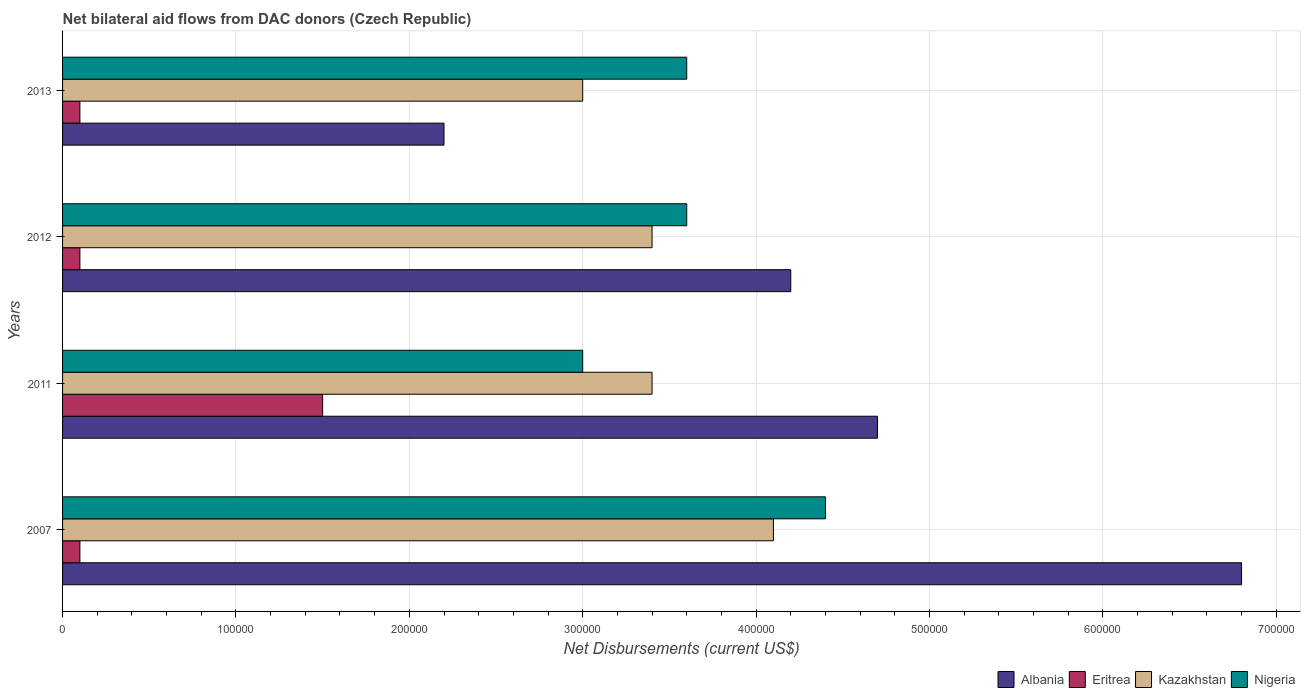How many different coloured bars are there?
Keep it short and to the point. 4. Are the number of bars per tick equal to the number of legend labels?
Offer a very short reply. Yes. What is the label of the 1st group of bars from the top?
Ensure brevity in your answer.  2013. What is the net bilateral aid flows in Nigeria in 2013?
Provide a succinct answer. 3.60e+05. Across all years, what is the maximum net bilateral aid flows in Kazakhstan?
Your answer should be very brief. 4.10e+05. Across all years, what is the minimum net bilateral aid flows in Albania?
Offer a very short reply. 2.20e+05. What is the total net bilateral aid flows in Albania in the graph?
Keep it short and to the point. 1.79e+06. What is the difference between the net bilateral aid flows in Albania in 2007 and that in 2012?
Ensure brevity in your answer.  2.60e+05. What is the average net bilateral aid flows in Albania per year?
Your answer should be very brief. 4.48e+05. In the year 2012, what is the difference between the net bilateral aid flows in Nigeria and net bilateral aid flows in Albania?
Offer a terse response. -6.00e+04. In how many years, is the net bilateral aid flows in Eritrea greater than 100000 US$?
Provide a succinct answer. 1. What is the ratio of the net bilateral aid flows in Kazakhstan in 2011 to that in 2013?
Your answer should be very brief. 1.13. Is the difference between the net bilateral aid flows in Nigeria in 2007 and 2012 greater than the difference between the net bilateral aid flows in Albania in 2007 and 2012?
Offer a very short reply. No. What is the difference between the highest and the second highest net bilateral aid flows in Eritrea?
Provide a succinct answer. 1.40e+05. What is the difference between the highest and the lowest net bilateral aid flows in Nigeria?
Make the answer very short. 1.40e+05. Is the sum of the net bilateral aid flows in Nigeria in 2011 and 2012 greater than the maximum net bilateral aid flows in Albania across all years?
Provide a short and direct response. No. Is it the case that in every year, the sum of the net bilateral aid flows in Nigeria and net bilateral aid flows in Albania is greater than the sum of net bilateral aid flows in Kazakhstan and net bilateral aid flows in Eritrea?
Your answer should be very brief. No. What does the 3rd bar from the top in 2007 represents?
Your answer should be very brief. Eritrea. What does the 2nd bar from the bottom in 2011 represents?
Make the answer very short. Eritrea. Is it the case that in every year, the sum of the net bilateral aid flows in Eritrea and net bilateral aid flows in Kazakhstan is greater than the net bilateral aid flows in Nigeria?
Give a very brief answer. No. What is the difference between two consecutive major ticks on the X-axis?
Offer a terse response. 1.00e+05. How many legend labels are there?
Keep it short and to the point. 4. How are the legend labels stacked?
Make the answer very short. Horizontal. What is the title of the graph?
Your answer should be compact. Net bilateral aid flows from DAC donors (Czech Republic). Does "Middle East & North Africa (developing only)" appear as one of the legend labels in the graph?
Keep it short and to the point. No. What is the label or title of the X-axis?
Your answer should be compact. Net Disbursements (current US$). What is the label or title of the Y-axis?
Make the answer very short. Years. What is the Net Disbursements (current US$) in Albania in 2007?
Offer a very short reply. 6.80e+05. What is the Net Disbursements (current US$) in Albania in 2011?
Your answer should be compact. 4.70e+05. What is the Net Disbursements (current US$) in Eritrea in 2011?
Your answer should be compact. 1.50e+05. What is the Net Disbursements (current US$) in Nigeria in 2011?
Keep it short and to the point. 3.00e+05. What is the Net Disbursements (current US$) of Albania in 2012?
Keep it short and to the point. 4.20e+05. What is the Net Disbursements (current US$) of Nigeria in 2012?
Provide a succinct answer. 3.60e+05. What is the Net Disbursements (current US$) of Eritrea in 2013?
Provide a short and direct response. 10000. What is the Net Disbursements (current US$) of Kazakhstan in 2013?
Offer a very short reply. 3.00e+05. What is the Net Disbursements (current US$) in Nigeria in 2013?
Offer a terse response. 3.60e+05. Across all years, what is the maximum Net Disbursements (current US$) in Albania?
Your answer should be very brief. 6.80e+05. Across all years, what is the maximum Net Disbursements (current US$) of Kazakhstan?
Keep it short and to the point. 4.10e+05. Across all years, what is the minimum Net Disbursements (current US$) in Albania?
Offer a terse response. 2.20e+05. Across all years, what is the minimum Net Disbursements (current US$) in Eritrea?
Ensure brevity in your answer.  10000. Across all years, what is the minimum Net Disbursements (current US$) of Nigeria?
Keep it short and to the point. 3.00e+05. What is the total Net Disbursements (current US$) of Albania in the graph?
Offer a very short reply. 1.79e+06. What is the total Net Disbursements (current US$) in Eritrea in the graph?
Offer a terse response. 1.80e+05. What is the total Net Disbursements (current US$) in Kazakhstan in the graph?
Provide a succinct answer. 1.39e+06. What is the total Net Disbursements (current US$) in Nigeria in the graph?
Offer a very short reply. 1.46e+06. What is the difference between the Net Disbursements (current US$) of Eritrea in 2007 and that in 2011?
Offer a very short reply. -1.40e+05. What is the difference between the Net Disbursements (current US$) in Nigeria in 2007 and that in 2011?
Your response must be concise. 1.40e+05. What is the difference between the Net Disbursements (current US$) of Albania in 2007 and that in 2012?
Provide a succinct answer. 2.60e+05. What is the difference between the Net Disbursements (current US$) of Eritrea in 2007 and that in 2012?
Provide a succinct answer. 0. What is the difference between the Net Disbursements (current US$) of Kazakhstan in 2007 and that in 2012?
Your answer should be compact. 7.00e+04. What is the difference between the Net Disbursements (current US$) in Nigeria in 2007 and that in 2012?
Provide a succinct answer. 8.00e+04. What is the difference between the Net Disbursements (current US$) of Eritrea in 2007 and that in 2013?
Give a very brief answer. 0. What is the difference between the Net Disbursements (current US$) of Kazakhstan in 2007 and that in 2013?
Your answer should be very brief. 1.10e+05. What is the difference between the Net Disbursements (current US$) in Albania in 2011 and that in 2012?
Your answer should be very brief. 5.00e+04. What is the difference between the Net Disbursements (current US$) in Kazakhstan in 2011 and that in 2012?
Your answer should be compact. 0. What is the difference between the Net Disbursements (current US$) of Albania in 2011 and that in 2013?
Ensure brevity in your answer.  2.50e+05. What is the difference between the Net Disbursements (current US$) in Eritrea in 2011 and that in 2013?
Provide a succinct answer. 1.40e+05. What is the difference between the Net Disbursements (current US$) in Nigeria in 2011 and that in 2013?
Provide a succinct answer. -6.00e+04. What is the difference between the Net Disbursements (current US$) in Eritrea in 2012 and that in 2013?
Your answer should be compact. 0. What is the difference between the Net Disbursements (current US$) of Nigeria in 2012 and that in 2013?
Your answer should be very brief. 0. What is the difference between the Net Disbursements (current US$) of Albania in 2007 and the Net Disbursements (current US$) of Eritrea in 2011?
Offer a very short reply. 5.30e+05. What is the difference between the Net Disbursements (current US$) of Eritrea in 2007 and the Net Disbursements (current US$) of Kazakhstan in 2011?
Your answer should be compact. -3.30e+05. What is the difference between the Net Disbursements (current US$) in Eritrea in 2007 and the Net Disbursements (current US$) in Nigeria in 2011?
Offer a terse response. -2.90e+05. What is the difference between the Net Disbursements (current US$) of Kazakhstan in 2007 and the Net Disbursements (current US$) of Nigeria in 2011?
Your answer should be very brief. 1.10e+05. What is the difference between the Net Disbursements (current US$) in Albania in 2007 and the Net Disbursements (current US$) in Eritrea in 2012?
Your response must be concise. 6.70e+05. What is the difference between the Net Disbursements (current US$) of Eritrea in 2007 and the Net Disbursements (current US$) of Kazakhstan in 2012?
Make the answer very short. -3.30e+05. What is the difference between the Net Disbursements (current US$) of Eritrea in 2007 and the Net Disbursements (current US$) of Nigeria in 2012?
Offer a terse response. -3.50e+05. What is the difference between the Net Disbursements (current US$) in Kazakhstan in 2007 and the Net Disbursements (current US$) in Nigeria in 2012?
Provide a succinct answer. 5.00e+04. What is the difference between the Net Disbursements (current US$) in Albania in 2007 and the Net Disbursements (current US$) in Eritrea in 2013?
Your answer should be very brief. 6.70e+05. What is the difference between the Net Disbursements (current US$) of Albania in 2007 and the Net Disbursements (current US$) of Kazakhstan in 2013?
Provide a short and direct response. 3.80e+05. What is the difference between the Net Disbursements (current US$) of Albania in 2007 and the Net Disbursements (current US$) of Nigeria in 2013?
Ensure brevity in your answer.  3.20e+05. What is the difference between the Net Disbursements (current US$) in Eritrea in 2007 and the Net Disbursements (current US$) in Nigeria in 2013?
Make the answer very short. -3.50e+05. What is the difference between the Net Disbursements (current US$) in Albania in 2011 and the Net Disbursements (current US$) in Eritrea in 2012?
Provide a succinct answer. 4.60e+05. What is the difference between the Net Disbursements (current US$) in Albania in 2011 and the Net Disbursements (current US$) in Kazakhstan in 2012?
Offer a terse response. 1.30e+05. What is the difference between the Net Disbursements (current US$) of Albania in 2011 and the Net Disbursements (current US$) of Eritrea in 2013?
Offer a very short reply. 4.60e+05. What is the difference between the Net Disbursements (current US$) in Albania in 2011 and the Net Disbursements (current US$) in Kazakhstan in 2013?
Offer a very short reply. 1.70e+05. What is the difference between the Net Disbursements (current US$) in Albania in 2011 and the Net Disbursements (current US$) in Nigeria in 2013?
Keep it short and to the point. 1.10e+05. What is the difference between the Net Disbursements (current US$) of Eritrea in 2011 and the Net Disbursements (current US$) of Kazakhstan in 2013?
Ensure brevity in your answer.  -1.50e+05. What is the difference between the Net Disbursements (current US$) in Kazakhstan in 2011 and the Net Disbursements (current US$) in Nigeria in 2013?
Your answer should be compact. -2.00e+04. What is the difference between the Net Disbursements (current US$) in Albania in 2012 and the Net Disbursements (current US$) in Eritrea in 2013?
Provide a short and direct response. 4.10e+05. What is the difference between the Net Disbursements (current US$) in Eritrea in 2012 and the Net Disbursements (current US$) in Kazakhstan in 2013?
Your answer should be compact. -2.90e+05. What is the difference between the Net Disbursements (current US$) in Eritrea in 2012 and the Net Disbursements (current US$) in Nigeria in 2013?
Keep it short and to the point. -3.50e+05. What is the difference between the Net Disbursements (current US$) of Kazakhstan in 2012 and the Net Disbursements (current US$) of Nigeria in 2013?
Ensure brevity in your answer.  -2.00e+04. What is the average Net Disbursements (current US$) in Albania per year?
Offer a terse response. 4.48e+05. What is the average Net Disbursements (current US$) in Eritrea per year?
Give a very brief answer. 4.50e+04. What is the average Net Disbursements (current US$) in Kazakhstan per year?
Your answer should be compact. 3.48e+05. What is the average Net Disbursements (current US$) in Nigeria per year?
Offer a terse response. 3.65e+05. In the year 2007, what is the difference between the Net Disbursements (current US$) of Albania and Net Disbursements (current US$) of Eritrea?
Your answer should be compact. 6.70e+05. In the year 2007, what is the difference between the Net Disbursements (current US$) in Albania and Net Disbursements (current US$) in Nigeria?
Give a very brief answer. 2.40e+05. In the year 2007, what is the difference between the Net Disbursements (current US$) in Eritrea and Net Disbursements (current US$) in Kazakhstan?
Provide a succinct answer. -4.00e+05. In the year 2007, what is the difference between the Net Disbursements (current US$) of Eritrea and Net Disbursements (current US$) of Nigeria?
Provide a succinct answer. -4.30e+05. In the year 2007, what is the difference between the Net Disbursements (current US$) of Kazakhstan and Net Disbursements (current US$) of Nigeria?
Provide a succinct answer. -3.00e+04. In the year 2011, what is the difference between the Net Disbursements (current US$) of Albania and Net Disbursements (current US$) of Eritrea?
Your answer should be very brief. 3.20e+05. In the year 2011, what is the difference between the Net Disbursements (current US$) of Eritrea and Net Disbursements (current US$) of Kazakhstan?
Offer a terse response. -1.90e+05. In the year 2011, what is the difference between the Net Disbursements (current US$) of Eritrea and Net Disbursements (current US$) of Nigeria?
Give a very brief answer. -1.50e+05. In the year 2011, what is the difference between the Net Disbursements (current US$) of Kazakhstan and Net Disbursements (current US$) of Nigeria?
Ensure brevity in your answer.  4.00e+04. In the year 2012, what is the difference between the Net Disbursements (current US$) of Eritrea and Net Disbursements (current US$) of Kazakhstan?
Offer a terse response. -3.30e+05. In the year 2012, what is the difference between the Net Disbursements (current US$) of Eritrea and Net Disbursements (current US$) of Nigeria?
Make the answer very short. -3.50e+05. In the year 2012, what is the difference between the Net Disbursements (current US$) in Kazakhstan and Net Disbursements (current US$) in Nigeria?
Ensure brevity in your answer.  -2.00e+04. In the year 2013, what is the difference between the Net Disbursements (current US$) of Albania and Net Disbursements (current US$) of Eritrea?
Your answer should be very brief. 2.10e+05. In the year 2013, what is the difference between the Net Disbursements (current US$) of Albania and Net Disbursements (current US$) of Kazakhstan?
Offer a terse response. -8.00e+04. In the year 2013, what is the difference between the Net Disbursements (current US$) in Eritrea and Net Disbursements (current US$) in Kazakhstan?
Make the answer very short. -2.90e+05. In the year 2013, what is the difference between the Net Disbursements (current US$) of Eritrea and Net Disbursements (current US$) of Nigeria?
Your answer should be compact. -3.50e+05. In the year 2013, what is the difference between the Net Disbursements (current US$) of Kazakhstan and Net Disbursements (current US$) of Nigeria?
Keep it short and to the point. -6.00e+04. What is the ratio of the Net Disbursements (current US$) of Albania in 2007 to that in 2011?
Your answer should be compact. 1.45. What is the ratio of the Net Disbursements (current US$) in Eritrea in 2007 to that in 2011?
Offer a very short reply. 0.07. What is the ratio of the Net Disbursements (current US$) in Kazakhstan in 2007 to that in 2011?
Your answer should be very brief. 1.21. What is the ratio of the Net Disbursements (current US$) of Nigeria in 2007 to that in 2011?
Offer a very short reply. 1.47. What is the ratio of the Net Disbursements (current US$) of Albania in 2007 to that in 2012?
Keep it short and to the point. 1.62. What is the ratio of the Net Disbursements (current US$) of Kazakhstan in 2007 to that in 2012?
Keep it short and to the point. 1.21. What is the ratio of the Net Disbursements (current US$) of Nigeria in 2007 to that in 2012?
Your answer should be very brief. 1.22. What is the ratio of the Net Disbursements (current US$) in Albania in 2007 to that in 2013?
Your response must be concise. 3.09. What is the ratio of the Net Disbursements (current US$) of Eritrea in 2007 to that in 2013?
Keep it short and to the point. 1. What is the ratio of the Net Disbursements (current US$) in Kazakhstan in 2007 to that in 2013?
Your response must be concise. 1.37. What is the ratio of the Net Disbursements (current US$) of Nigeria in 2007 to that in 2013?
Provide a short and direct response. 1.22. What is the ratio of the Net Disbursements (current US$) in Albania in 2011 to that in 2012?
Your response must be concise. 1.12. What is the ratio of the Net Disbursements (current US$) in Kazakhstan in 2011 to that in 2012?
Offer a very short reply. 1. What is the ratio of the Net Disbursements (current US$) of Nigeria in 2011 to that in 2012?
Your answer should be compact. 0.83. What is the ratio of the Net Disbursements (current US$) of Albania in 2011 to that in 2013?
Make the answer very short. 2.14. What is the ratio of the Net Disbursements (current US$) of Eritrea in 2011 to that in 2013?
Ensure brevity in your answer.  15. What is the ratio of the Net Disbursements (current US$) in Kazakhstan in 2011 to that in 2013?
Give a very brief answer. 1.13. What is the ratio of the Net Disbursements (current US$) of Albania in 2012 to that in 2013?
Give a very brief answer. 1.91. What is the ratio of the Net Disbursements (current US$) of Eritrea in 2012 to that in 2013?
Ensure brevity in your answer.  1. What is the ratio of the Net Disbursements (current US$) in Kazakhstan in 2012 to that in 2013?
Provide a succinct answer. 1.13. What is the ratio of the Net Disbursements (current US$) in Nigeria in 2012 to that in 2013?
Your answer should be compact. 1. What is the difference between the highest and the second highest Net Disbursements (current US$) of Eritrea?
Give a very brief answer. 1.40e+05. What is the difference between the highest and the lowest Net Disbursements (current US$) in Albania?
Ensure brevity in your answer.  4.60e+05. What is the difference between the highest and the lowest Net Disbursements (current US$) in Eritrea?
Offer a very short reply. 1.40e+05. What is the difference between the highest and the lowest Net Disbursements (current US$) of Kazakhstan?
Give a very brief answer. 1.10e+05. What is the difference between the highest and the lowest Net Disbursements (current US$) of Nigeria?
Your answer should be very brief. 1.40e+05. 